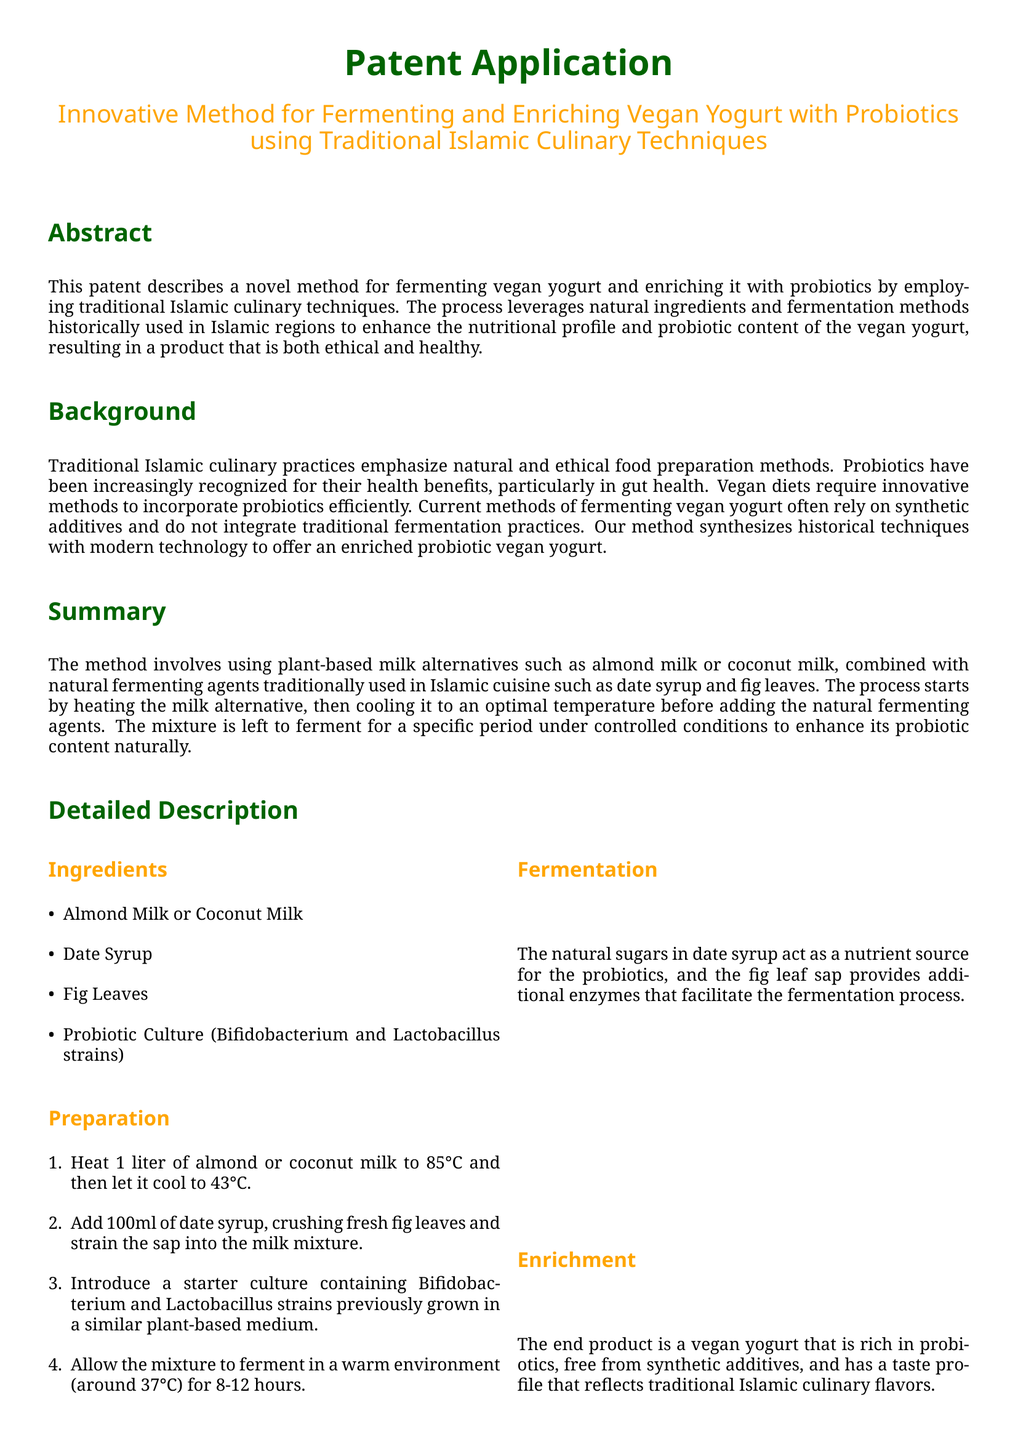What is the main focus of the patent? The patent describes a novel method for fermenting vegan yogurt and enriching it with probiotics using traditional Islamic culinary techniques.
Answer: vegan yogurt What plant-based milk alternatives are used? The ingredients section lists the plant-based milk alternatives that can be used in the method, which are specified in the document.
Answer: Almond Milk or Coconut Milk What natural fermenting agents are mentioned? The document details natural fermenting agents traditionally used in Islamic cuisine that enhance the yogurt's probiotic content.
Answer: Date Syrup and Fig Leaves How long does the fermentation process take? The method specifies the range of time under controlled conditions for the fermentation process.
Answer: 8-12 hours What probiotic strains are used in the culture? The probiotic culture mentioned in the preparation process specifies the strains utilized in the yogurt fermentation.
Answer: Bifidobacterium and Lactobacillus What temperature is the milk cooled to before adding ingredients? The detailed preparation section indicates the temperature to which the heated milk is cooled before adding other ingredients.
Answer: 43°C What is the advantage of using natural sugars in the fermentation? The advantages section highlights the benefits of natural sugars present in the fermenting agent's role in the fermentation process.
Answer: Enhanced probiotic content What is the purpose of fig leaf sap in the process? The explanation of fermentation in the document describes the role of fig leaf sap in the yogurt's development.
Answer: Provides additional enzymes What type of document is this? The document is identified and classified at the beginning, specifying its nature and function within legal boundaries.
Answer: Patent Application What does the method align with? The advantages section notes the ethical considerations in food production practices, reflecting its adherence to a specific dietary framework.
Answer: Islamic dietary laws 